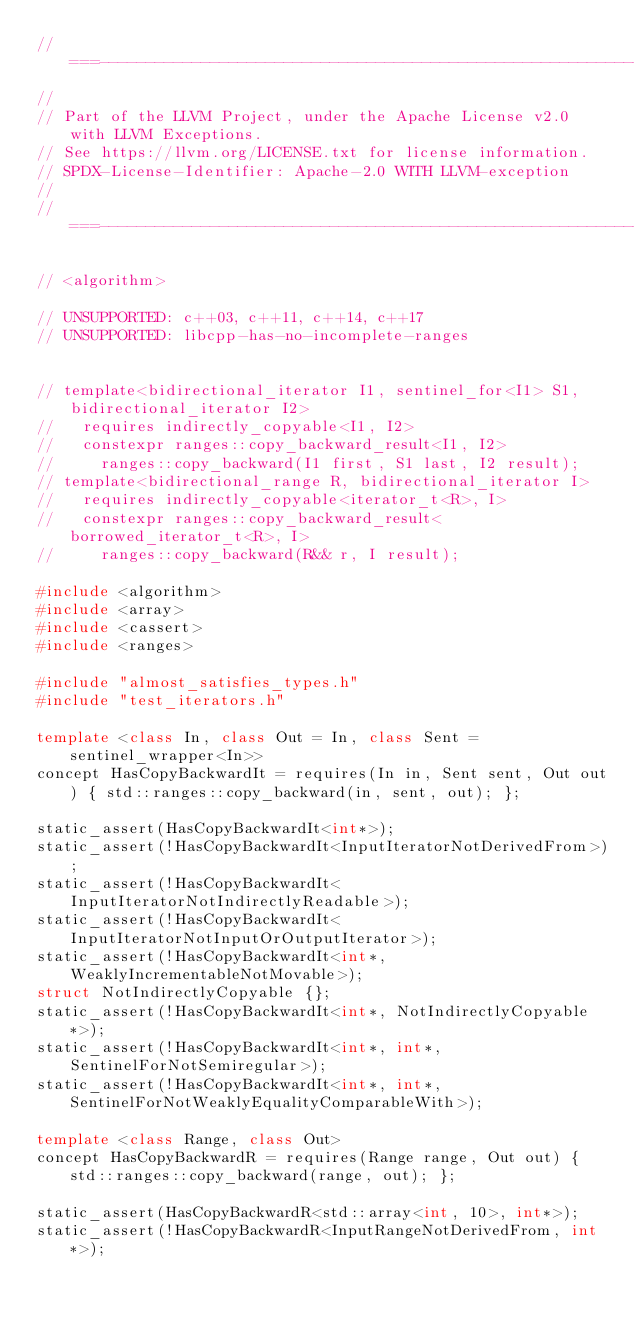<code> <loc_0><loc_0><loc_500><loc_500><_C++_>//===----------------------------------------------------------------------===//
//
// Part of the LLVM Project, under the Apache License v2.0 with LLVM Exceptions.
// See https://llvm.org/LICENSE.txt for license information.
// SPDX-License-Identifier: Apache-2.0 WITH LLVM-exception
//
//===----------------------------------------------------------------------===//

// <algorithm>

// UNSUPPORTED: c++03, c++11, c++14, c++17
// UNSUPPORTED: libcpp-has-no-incomplete-ranges


// template<bidirectional_iterator I1, sentinel_for<I1> S1, bidirectional_iterator I2>
//   requires indirectly_copyable<I1, I2>
//   constexpr ranges::copy_backward_result<I1, I2>
//     ranges::copy_backward(I1 first, S1 last, I2 result);
// template<bidirectional_range R, bidirectional_iterator I>
//   requires indirectly_copyable<iterator_t<R>, I>
//   constexpr ranges::copy_backward_result<borrowed_iterator_t<R>, I>
//     ranges::copy_backward(R&& r, I result);

#include <algorithm>
#include <array>
#include <cassert>
#include <ranges>

#include "almost_satisfies_types.h"
#include "test_iterators.h"

template <class In, class Out = In, class Sent = sentinel_wrapper<In>>
concept HasCopyBackwardIt = requires(In in, Sent sent, Out out) { std::ranges::copy_backward(in, sent, out); };

static_assert(HasCopyBackwardIt<int*>);
static_assert(!HasCopyBackwardIt<InputIteratorNotDerivedFrom>);
static_assert(!HasCopyBackwardIt<InputIteratorNotIndirectlyReadable>);
static_assert(!HasCopyBackwardIt<InputIteratorNotInputOrOutputIterator>);
static_assert(!HasCopyBackwardIt<int*, WeaklyIncrementableNotMovable>);
struct NotIndirectlyCopyable {};
static_assert(!HasCopyBackwardIt<int*, NotIndirectlyCopyable*>);
static_assert(!HasCopyBackwardIt<int*, int*, SentinelForNotSemiregular>);
static_assert(!HasCopyBackwardIt<int*, int*, SentinelForNotWeaklyEqualityComparableWith>);

template <class Range, class Out>
concept HasCopyBackwardR = requires(Range range, Out out) { std::ranges::copy_backward(range, out); };

static_assert(HasCopyBackwardR<std::array<int, 10>, int*>);
static_assert(!HasCopyBackwardR<InputRangeNotDerivedFrom, int*>);</code> 